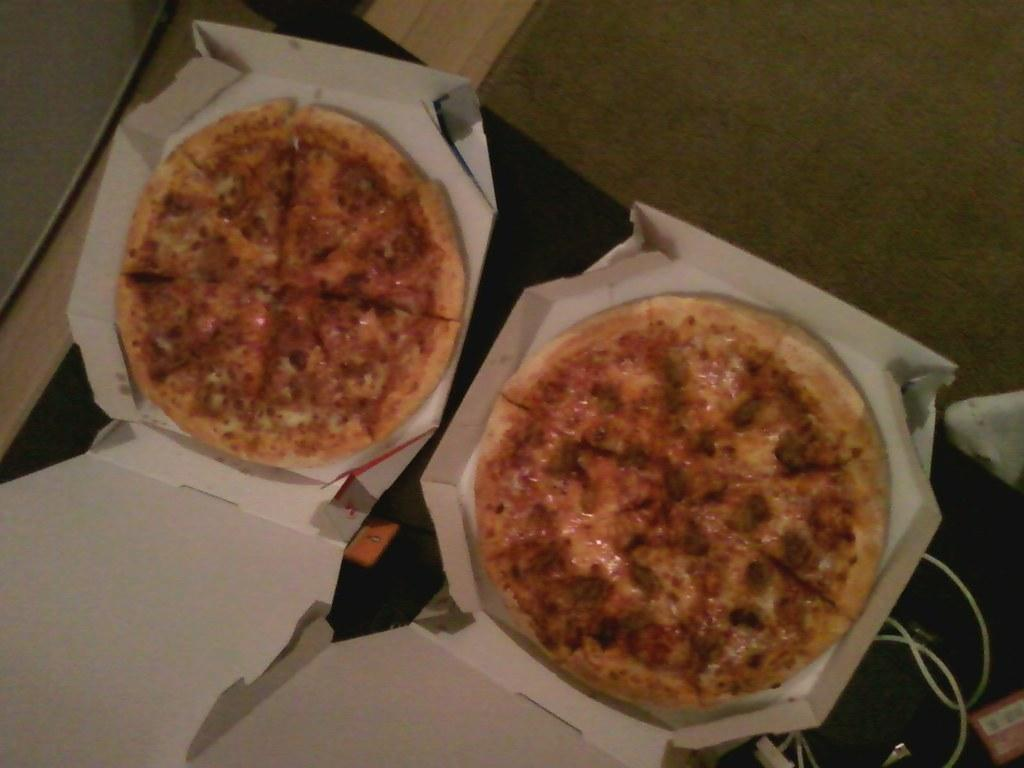What type of food is visible in the image? There are pizzas in the image. How are the pizzas stored or contained? The pizzas are kept in boxes. Where are the boxes with pizzas located? The boxes are placed on a table. What type of fuel is being used to power the pizzas in the image? There is no fuel present in the image, as pizzas do not require fuel to function. 